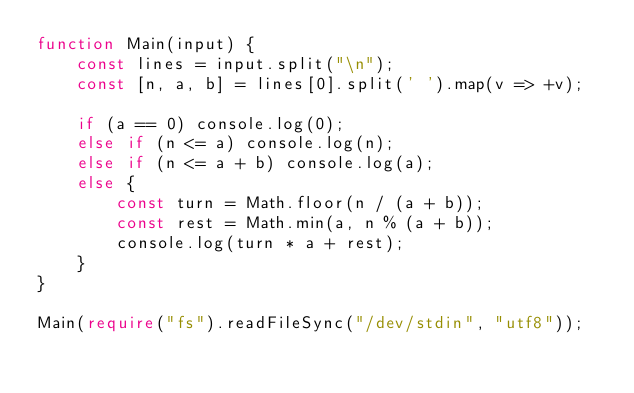Convert code to text. <code><loc_0><loc_0><loc_500><loc_500><_TypeScript_>function Main(input) {
    const lines = input.split("\n");
    const [n, a, b] = lines[0].split(' ').map(v => +v);

    if (a == 0) console.log(0);
    else if (n <= a) console.log(n);
    else if (n <= a + b) console.log(a);
    else {
        const turn = Math.floor(n / (a + b));
        const rest = Math.min(a, n % (a + b));
        console.log(turn * a + rest);
    }
}

Main(require("fs").readFileSync("/dev/stdin", "utf8"));</code> 